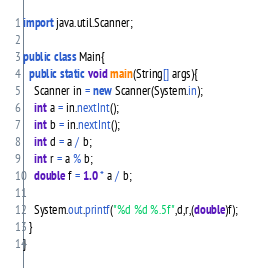<code> <loc_0><loc_0><loc_500><loc_500><_Java_>import java.util.Scanner;

public class Main{
  public static void main(String[] args){
    Scanner in = new Scanner(System.in);
    int a = in.nextInt();
    int b = in.nextInt();
    int d = a / b;
    int r = a % b;
    double f = 1.0 * a / b;
    
    System.out.printf("%d %d %.5f",d,r,(double)f);
  }
}</code> 